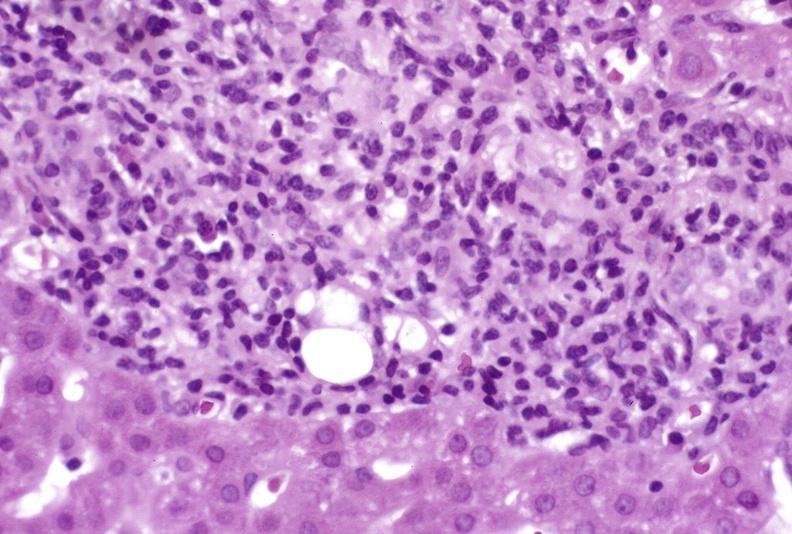what is present?
Answer the question using a single word or phrase. Hepatobiliary 